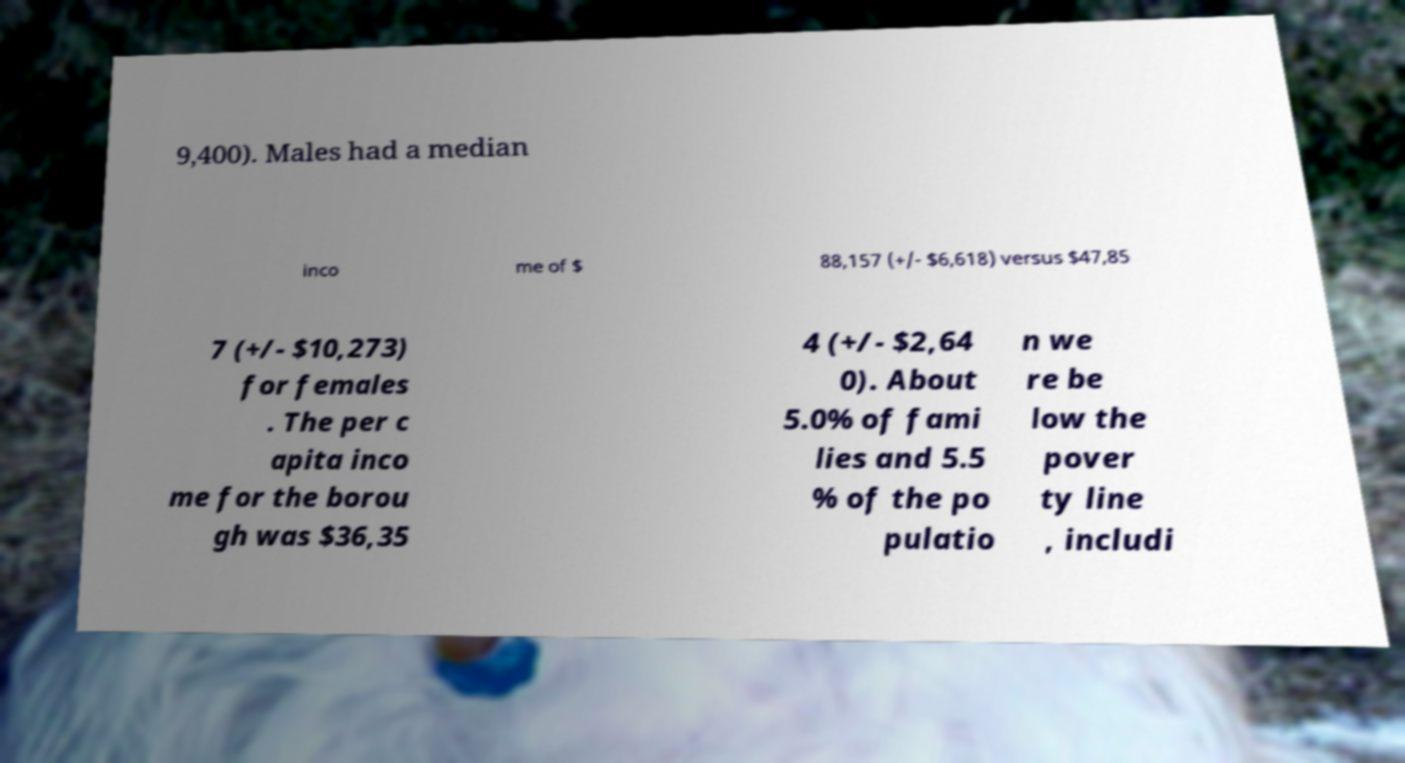Can you read and provide the text displayed in the image?This photo seems to have some interesting text. Can you extract and type it out for me? 9,400). Males had a median inco me of $ 88,157 (+/- $6,618) versus $47,85 7 (+/- $10,273) for females . The per c apita inco me for the borou gh was $36,35 4 (+/- $2,64 0). About 5.0% of fami lies and 5.5 % of the po pulatio n we re be low the pover ty line , includi 